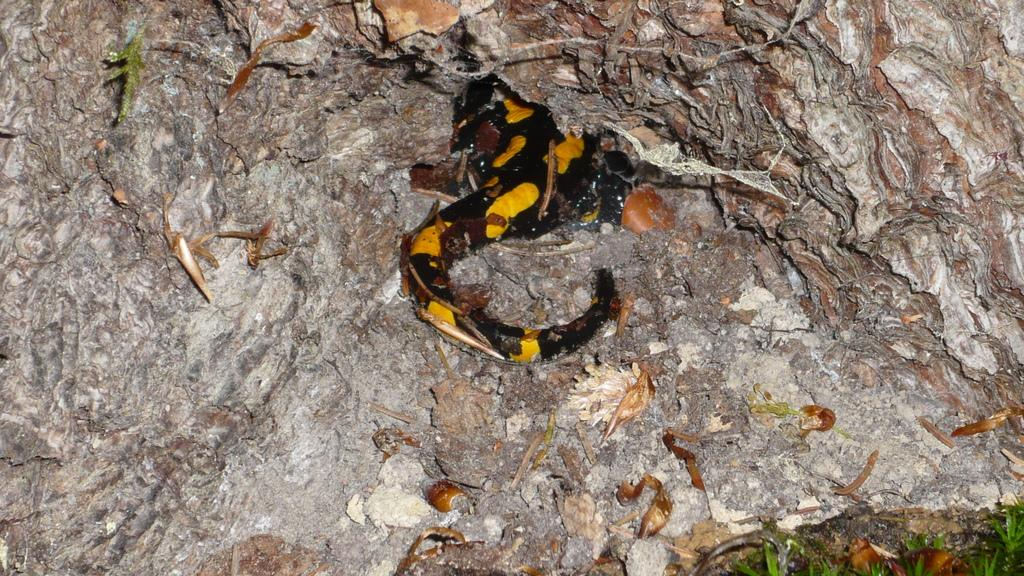What is the main object in the image? There is a rock in the image. What other living creature can be seen in the image? There is an animal in the image. What colors are present on the animal? The animal has yellow and black colors. What type of vegetation is visible in the image? There is green grass in the image. What type of twig is the animal using to communicate in the image? There is no twig present in the image, and the animal is not communicating with any object. 